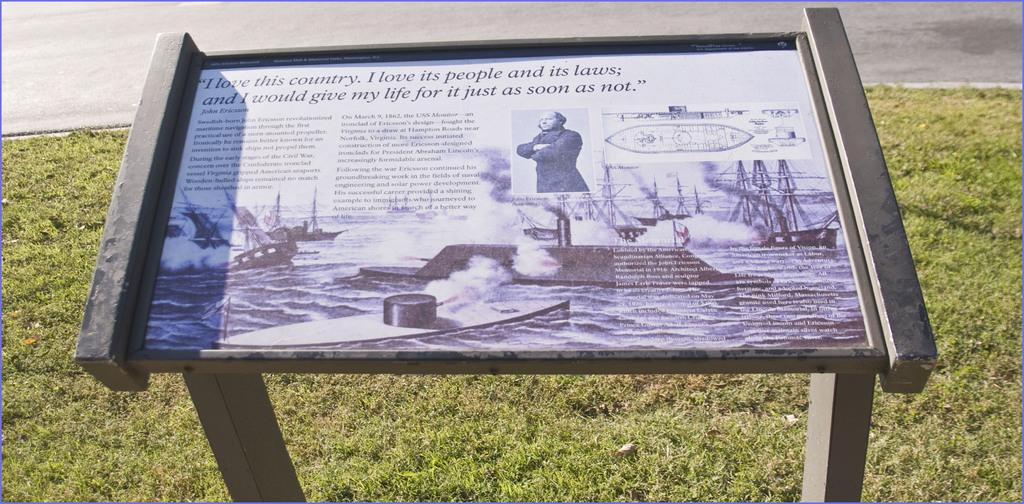What is the main object in the image? There is a frame in the image. How is the frame positioned in the image? The frame is on a stand. What type of environment is visible in the image? There is grass visible in the image. What color is the orange in the image? There is no orange present in the image. What shape is the chess piece in the image? There is no chess piece present in the image. 